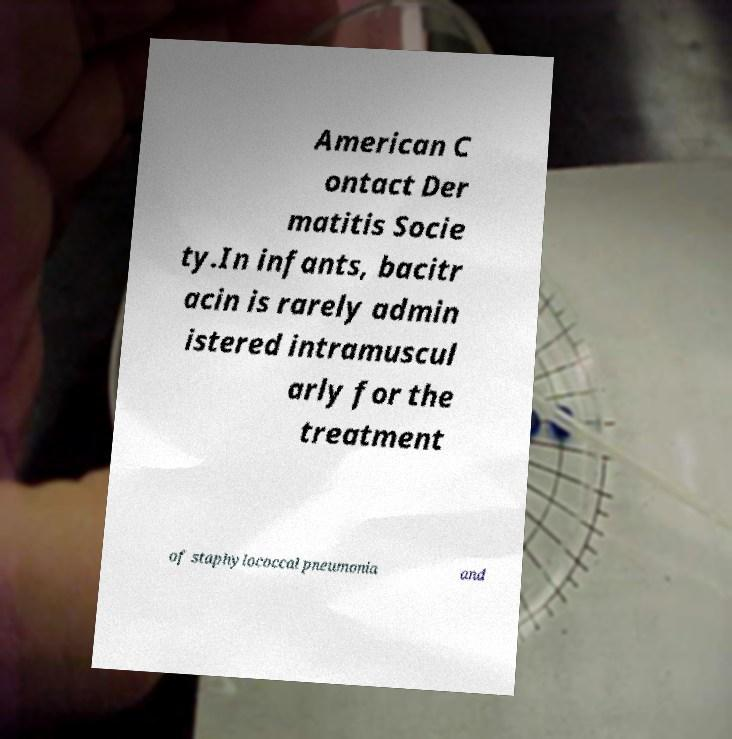Can you read and provide the text displayed in the image?This photo seems to have some interesting text. Can you extract and type it out for me? American C ontact Der matitis Socie ty.In infants, bacitr acin is rarely admin istered intramuscul arly for the treatment of staphylococcal pneumonia and 